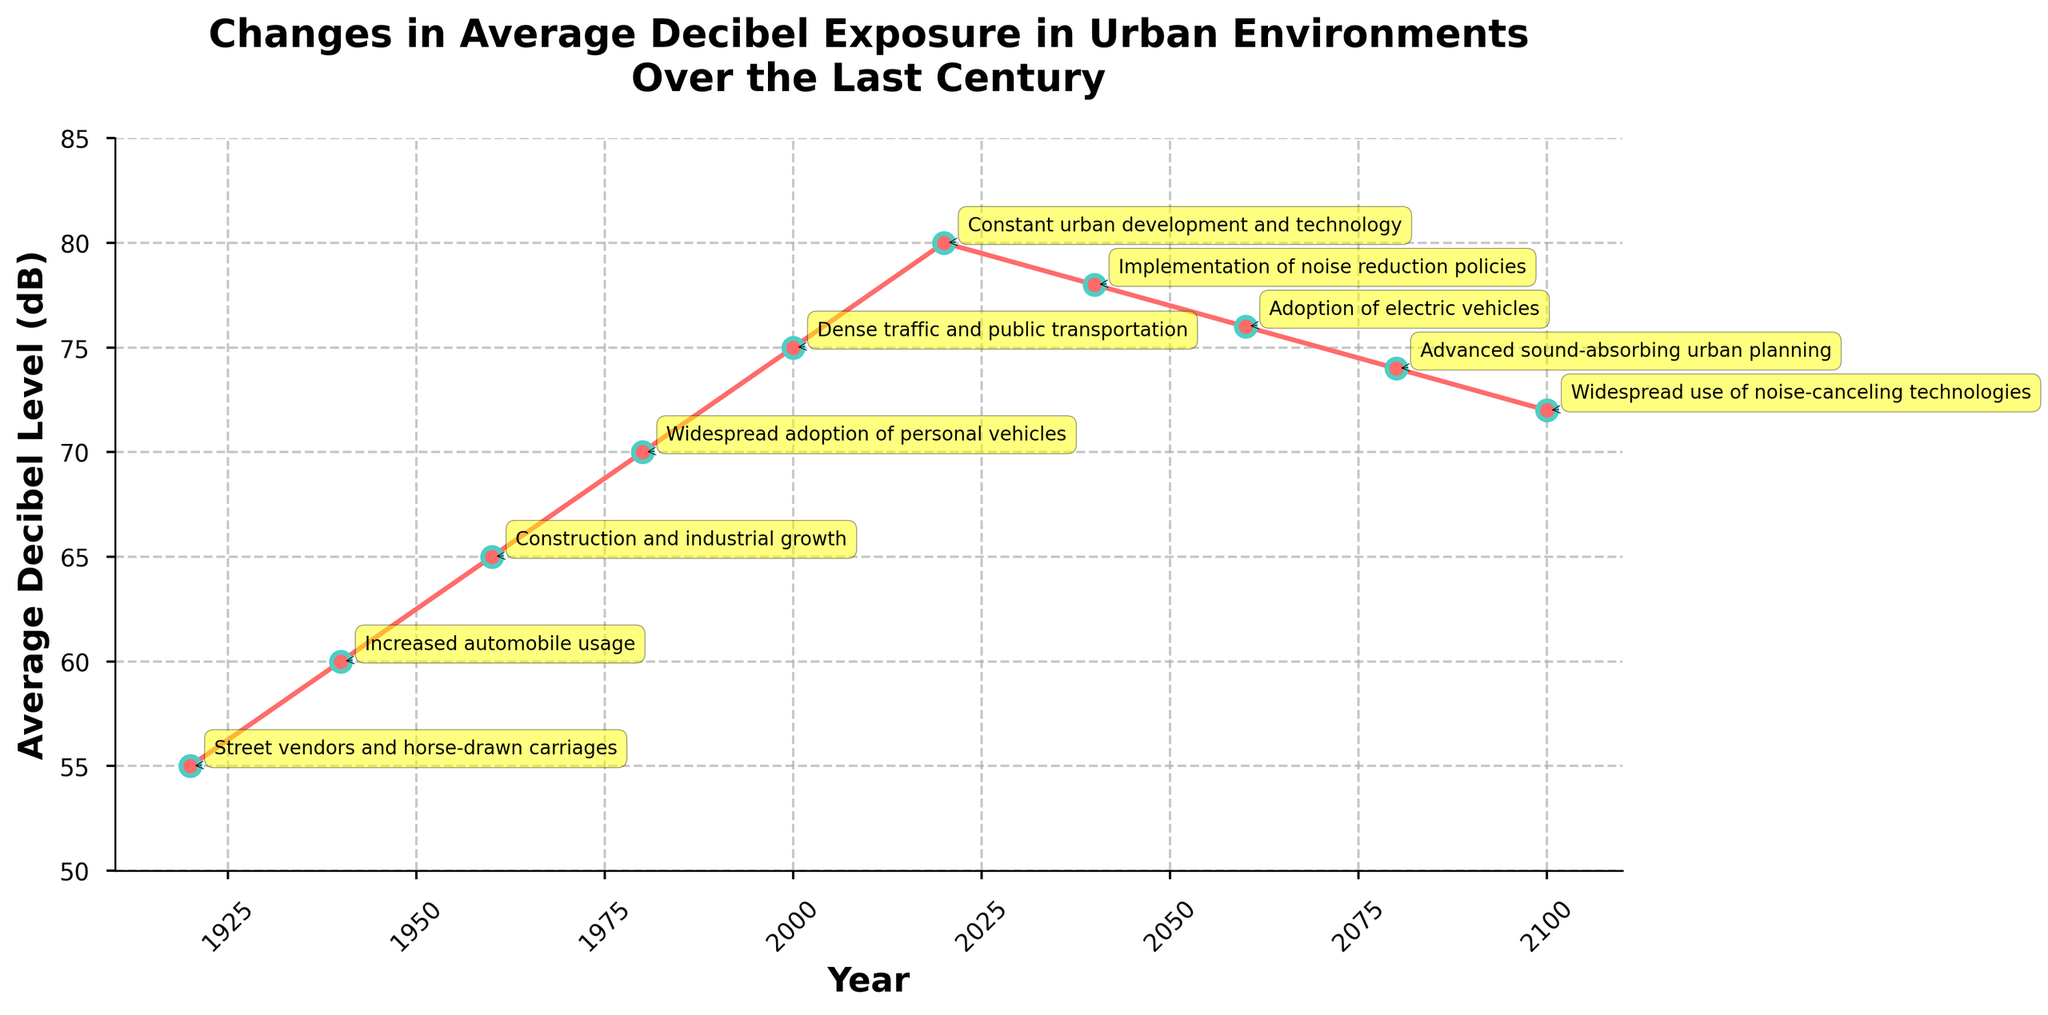What is the trend in average decibel level from 1920 to 2100? Observing the plot from 1920 to 2100, we see a general increase in the average decibel levels until 2020, followed by a gradual decrease due to noise reduction policies and technology advancements.
Answer: Gradually increasing until 2020, then decreasing Which year marks the peak of average decibel exposure, and what was the level? The peak of the average decibel level occurs in 2020, as indicated by the highest point on the plot. The corresponding decibel level is 80 dB.
Answer: 2020, 80 dB How much did the average decibel level increase from 1920 to 2020? The average decibel level in 1920 was 55 dB, and it increased to 80 dB by 2020. The difference is 80 - 55 = 25 dB.
Answer: 25 dB Which period saw the most significant increase in average decibel levels, and by how much? The period between 2000 and 2020 saw the most significant increase, rising from 75 dB to 80 dB, a change of 5 dB.
Answer: 2000-2020, 5 dB How does the average decibel level in 2100 compare to that in 1960? The average decibel level in 2100 is 72 dB, while in 1960 it was 65 dB. Therefore, the level in 2100 is 72 - 65 = 7 dB higher than in 1960.
Answer: 7 dB higher What visual element highlights the major contributing factors for decibel levels in each year? Each contributing factor is annotated directly on the graph, marked by an arrow pointing to the data point, with a yellow boxed text for easier reading.
Answer: Yellow boxed text annotations with arrows Calculate the average decibel level for the years 1920, 1960, and 2100. The decibel levels for these years are 55 dB, 65 dB, and 72 dB. The average is calculated as (55 + 65 + 72) / 3 = 192 / 3 = 64 dB.
Answer: 64 dB Between which consecutive decades did the average decibel level first start to decline? Observing the graph, the first decline is seen between 2020 and 2040, where the level drops from 80 dB to 78 dB.
Answer: 2020-2040 What was the major contributing factor in 1940, and how did it impact the decibel level compared to 1920? In 1940, the major contributing factor was increased automobile usage. It raised the average decibel level from 55 dB in 1920 to 60 dB in 1940, an increase of 5 dB.
Answer: Increased automobile usage, 5 dB What is the general pattern of decibel levels from 2000 to 2100, and what contributing factors are observed? From 2000 to 2100, there is an initial increase in decibel levels until 2020, followed by a gradual decrease. Major contributing factors include dense traffic, noise reduction policies, electric vehicles, sound-absorbing urban planning, and noise-canceling technologies.
Answer: Increase till 2020, then decrease, influenced by traffic, policies, electric vehicles, urban planning, and noise-canceling technologies 